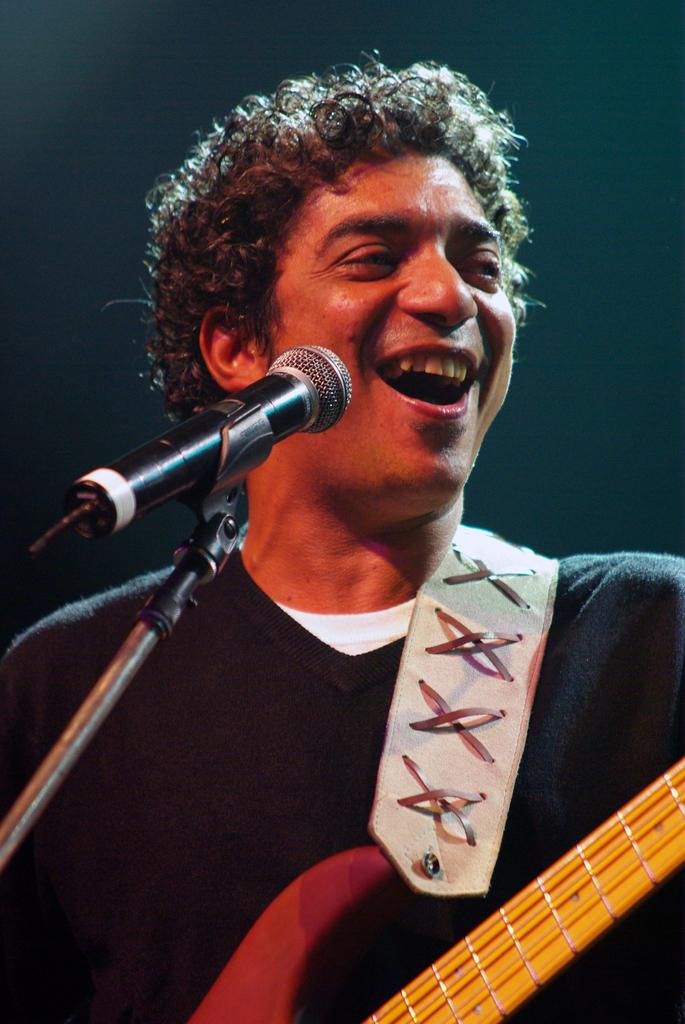What is the man in the image doing? The man is holding a guitar and singing with the help of a microphone. What expression does the man have on his face? The man has a smile on his face. What instrument is the man holding in the image? The man is holding a guitar. How many snails can be seen crawling on the guitar in the image? There are no snails present in the image; the man is holding a guitar, but there are no snails visible. 